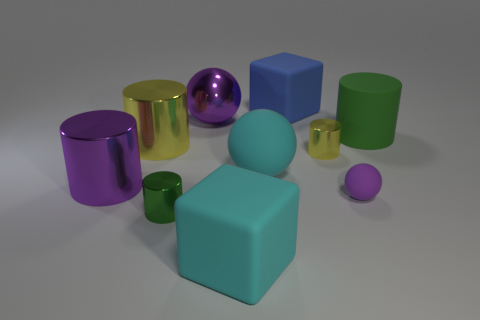Describe the lighting in the image. The lighting in the image is soft and diffused, coming from a source that is not directly visible in the frame. It casts gentle shadows on the right side of the objects, suggesting the light source is to the left of the scene. Does the lighting affect the color perception of the objects? Yes, the lighting can influence how we perceive the colors of the objects. The diffused light softens the colors, possibly making them appear slightly less saturated and altering how the reflective surfaces, like the metallic sphere, capture and reflect color from their surroundings. 